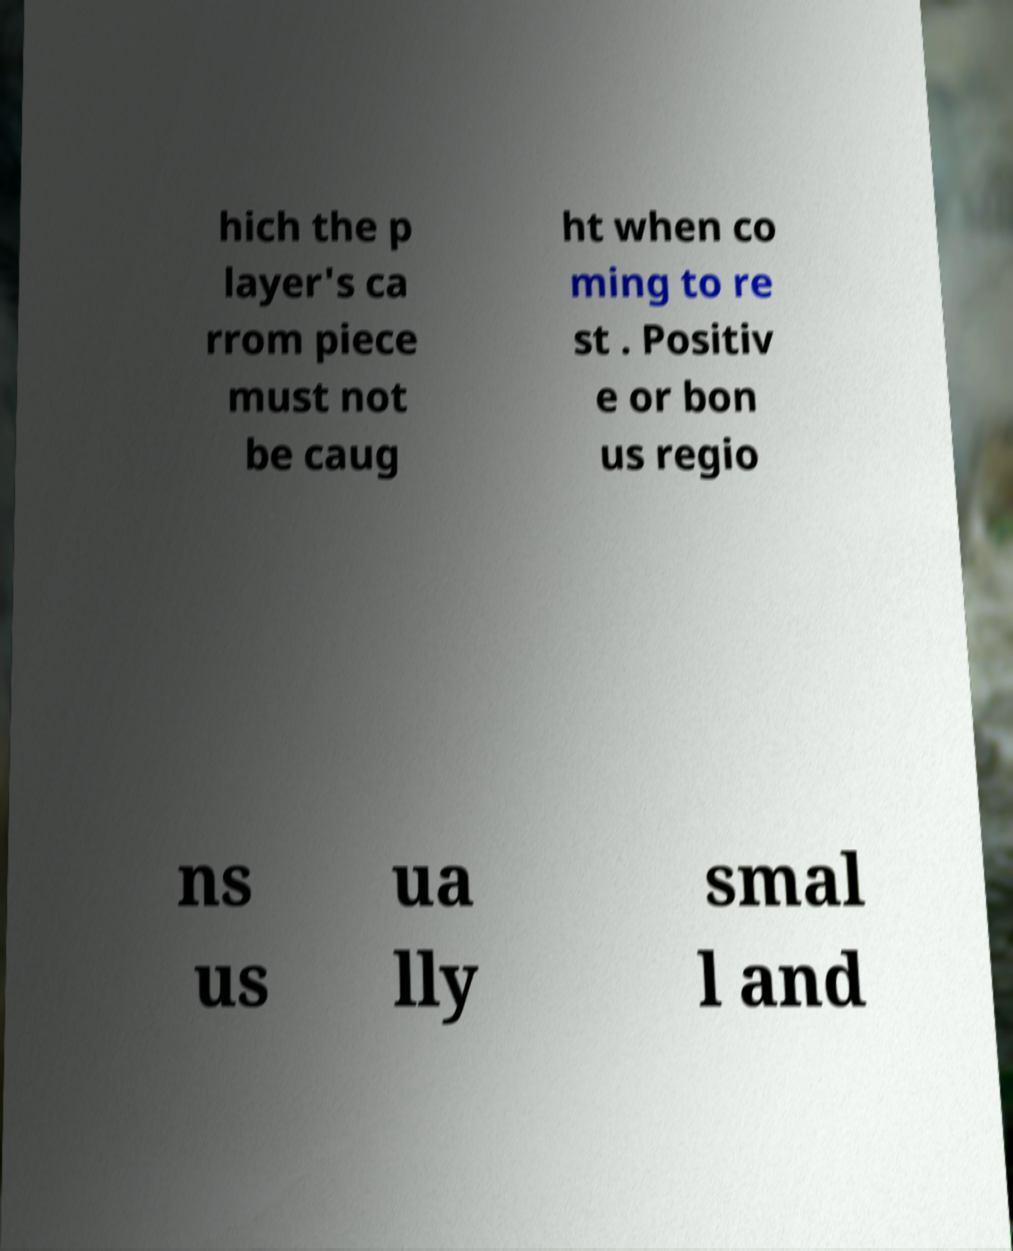Could you extract and type out the text from this image? hich the p layer's ca rrom piece must not be caug ht when co ming to re st . Positiv e or bon us regio ns us ua lly smal l and 